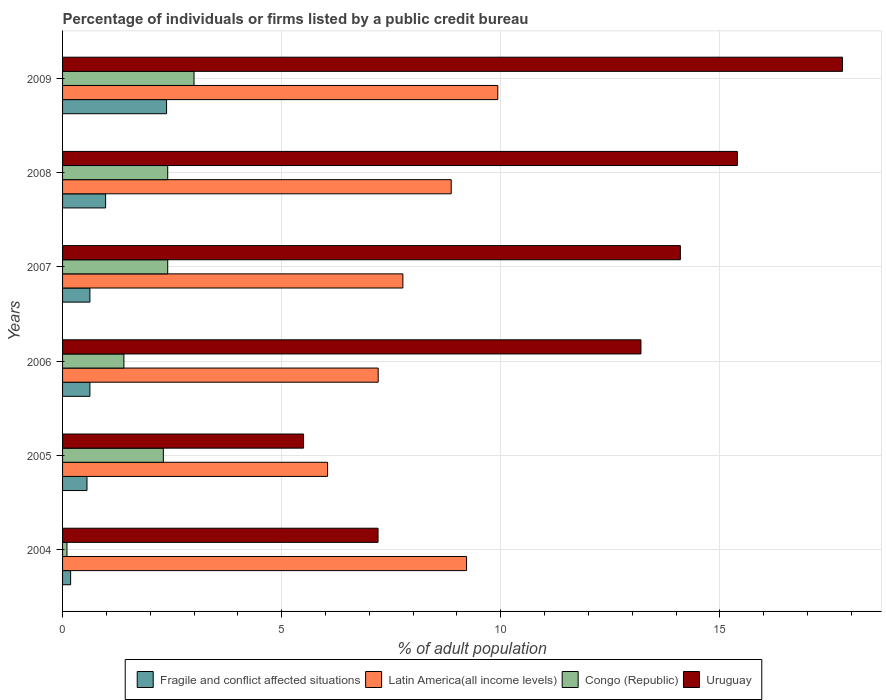Are the number of bars per tick equal to the number of legend labels?
Keep it short and to the point. Yes. Are the number of bars on each tick of the Y-axis equal?
Your response must be concise. Yes. How many bars are there on the 2nd tick from the top?
Your answer should be very brief. 4. What is the label of the 3rd group of bars from the top?
Offer a terse response. 2007. What is the percentage of population listed by a public credit bureau in Latin America(all income levels) in 2006?
Keep it short and to the point. 7.2. Across all years, what is the minimum percentage of population listed by a public credit bureau in Fragile and conflict affected situations?
Your response must be concise. 0.18. In which year was the percentage of population listed by a public credit bureau in Latin America(all income levels) minimum?
Ensure brevity in your answer.  2005. What is the total percentage of population listed by a public credit bureau in Fragile and conflict affected situations in the graph?
Provide a succinct answer. 5.35. What is the difference between the percentage of population listed by a public credit bureau in Congo (Republic) in 2004 and that in 2007?
Provide a short and direct response. -2.3. What is the difference between the percentage of population listed by a public credit bureau in Latin America(all income levels) in 2006 and the percentage of population listed by a public credit bureau in Uruguay in 2008?
Your response must be concise. -8.2. What is the average percentage of population listed by a public credit bureau in Fragile and conflict affected situations per year?
Keep it short and to the point. 0.89. In the year 2007, what is the difference between the percentage of population listed by a public credit bureau in Congo (Republic) and percentage of population listed by a public credit bureau in Latin America(all income levels)?
Offer a very short reply. -5.37. In how many years, is the percentage of population listed by a public credit bureau in Fragile and conflict affected situations greater than 2 %?
Give a very brief answer. 1. What is the ratio of the percentage of population listed by a public credit bureau in Fragile and conflict affected situations in 2004 to that in 2006?
Offer a terse response. 0.29. Is the percentage of population listed by a public credit bureau in Fragile and conflict affected situations in 2006 less than that in 2009?
Provide a succinct answer. Yes. Is the difference between the percentage of population listed by a public credit bureau in Congo (Republic) in 2006 and 2008 greater than the difference between the percentage of population listed by a public credit bureau in Latin America(all income levels) in 2006 and 2008?
Keep it short and to the point. Yes. What is the difference between the highest and the second highest percentage of population listed by a public credit bureau in Fragile and conflict affected situations?
Your response must be concise. 1.39. What does the 3rd bar from the top in 2006 represents?
Keep it short and to the point. Latin America(all income levels). What does the 3rd bar from the bottom in 2009 represents?
Your answer should be compact. Congo (Republic). Is it the case that in every year, the sum of the percentage of population listed by a public credit bureau in Latin America(all income levels) and percentage of population listed by a public credit bureau in Uruguay is greater than the percentage of population listed by a public credit bureau in Fragile and conflict affected situations?
Your response must be concise. Yes. How many bars are there?
Keep it short and to the point. 24. What is the difference between two consecutive major ticks on the X-axis?
Ensure brevity in your answer.  5. Where does the legend appear in the graph?
Make the answer very short. Bottom center. How many legend labels are there?
Your answer should be very brief. 4. What is the title of the graph?
Provide a succinct answer. Percentage of individuals or firms listed by a public credit bureau. Does "Lao PDR" appear as one of the legend labels in the graph?
Provide a short and direct response. No. What is the label or title of the X-axis?
Provide a short and direct response. % of adult population. What is the % of adult population in Fragile and conflict affected situations in 2004?
Your answer should be compact. 0.18. What is the % of adult population of Latin America(all income levels) in 2004?
Your response must be concise. 9.22. What is the % of adult population of Congo (Republic) in 2004?
Your answer should be compact. 0.1. What is the % of adult population of Uruguay in 2004?
Offer a very short reply. 7.2. What is the % of adult population in Fragile and conflict affected situations in 2005?
Provide a succinct answer. 0.56. What is the % of adult population of Latin America(all income levels) in 2005?
Offer a very short reply. 6.05. What is the % of adult population of Uruguay in 2005?
Keep it short and to the point. 5.5. What is the % of adult population of Fragile and conflict affected situations in 2006?
Your answer should be compact. 0.62. What is the % of adult population of Latin America(all income levels) in 2006?
Your response must be concise. 7.2. What is the % of adult population in Congo (Republic) in 2006?
Offer a very short reply. 1.4. What is the % of adult population in Fragile and conflict affected situations in 2007?
Make the answer very short. 0.62. What is the % of adult population in Latin America(all income levels) in 2007?
Your answer should be very brief. 7.77. What is the % of adult population in Fragile and conflict affected situations in 2008?
Make the answer very short. 0.98. What is the % of adult population in Latin America(all income levels) in 2008?
Give a very brief answer. 8.87. What is the % of adult population in Uruguay in 2008?
Provide a short and direct response. 15.4. What is the % of adult population of Fragile and conflict affected situations in 2009?
Provide a short and direct response. 2.37. What is the % of adult population in Latin America(all income levels) in 2009?
Keep it short and to the point. 9.93. Across all years, what is the maximum % of adult population of Fragile and conflict affected situations?
Offer a terse response. 2.37. Across all years, what is the maximum % of adult population in Latin America(all income levels)?
Provide a short and direct response. 9.93. Across all years, what is the maximum % of adult population in Uruguay?
Your answer should be very brief. 17.8. Across all years, what is the minimum % of adult population of Fragile and conflict affected situations?
Offer a very short reply. 0.18. Across all years, what is the minimum % of adult population in Latin America(all income levels)?
Offer a very short reply. 6.05. Across all years, what is the minimum % of adult population in Congo (Republic)?
Offer a terse response. 0.1. Across all years, what is the minimum % of adult population in Uruguay?
Keep it short and to the point. 5.5. What is the total % of adult population in Fragile and conflict affected situations in the graph?
Keep it short and to the point. 5.35. What is the total % of adult population of Latin America(all income levels) in the graph?
Offer a very short reply. 49.04. What is the total % of adult population of Congo (Republic) in the graph?
Your answer should be very brief. 11.6. What is the total % of adult population of Uruguay in the graph?
Provide a short and direct response. 73.2. What is the difference between the % of adult population of Fragile and conflict affected situations in 2004 and that in 2005?
Ensure brevity in your answer.  -0.37. What is the difference between the % of adult population in Latin America(all income levels) in 2004 and that in 2005?
Offer a very short reply. 3.17. What is the difference between the % of adult population in Uruguay in 2004 and that in 2005?
Your response must be concise. 1.7. What is the difference between the % of adult population of Fragile and conflict affected situations in 2004 and that in 2006?
Offer a very short reply. -0.44. What is the difference between the % of adult population in Latin America(all income levels) in 2004 and that in 2006?
Ensure brevity in your answer.  2.02. What is the difference between the % of adult population in Fragile and conflict affected situations in 2004 and that in 2007?
Provide a short and direct response. -0.44. What is the difference between the % of adult population of Latin America(all income levels) in 2004 and that in 2007?
Your answer should be compact. 1.45. What is the difference between the % of adult population in Congo (Republic) in 2004 and that in 2007?
Your response must be concise. -2.3. What is the difference between the % of adult population in Fragile and conflict affected situations in 2004 and that in 2008?
Offer a very short reply. -0.8. What is the difference between the % of adult population of Latin America(all income levels) in 2004 and that in 2008?
Provide a short and direct response. 0.35. What is the difference between the % of adult population of Fragile and conflict affected situations in 2004 and that in 2009?
Give a very brief answer. -2.19. What is the difference between the % of adult population of Latin America(all income levels) in 2004 and that in 2009?
Your response must be concise. -0.71. What is the difference between the % of adult population of Fragile and conflict affected situations in 2005 and that in 2006?
Offer a terse response. -0.07. What is the difference between the % of adult population in Latin America(all income levels) in 2005 and that in 2006?
Provide a short and direct response. -1.16. What is the difference between the % of adult population in Fragile and conflict affected situations in 2005 and that in 2007?
Your response must be concise. -0.07. What is the difference between the % of adult population in Latin America(all income levels) in 2005 and that in 2007?
Your answer should be very brief. -1.72. What is the difference between the % of adult population of Congo (Republic) in 2005 and that in 2007?
Provide a short and direct response. -0.1. What is the difference between the % of adult population in Fragile and conflict affected situations in 2005 and that in 2008?
Offer a terse response. -0.43. What is the difference between the % of adult population of Latin America(all income levels) in 2005 and that in 2008?
Provide a succinct answer. -2.82. What is the difference between the % of adult population of Fragile and conflict affected situations in 2005 and that in 2009?
Your answer should be very brief. -1.82. What is the difference between the % of adult population of Latin America(all income levels) in 2005 and that in 2009?
Give a very brief answer. -3.89. What is the difference between the % of adult population in Congo (Republic) in 2005 and that in 2009?
Keep it short and to the point. -0.7. What is the difference between the % of adult population of Latin America(all income levels) in 2006 and that in 2007?
Ensure brevity in your answer.  -0.56. What is the difference between the % of adult population in Congo (Republic) in 2006 and that in 2007?
Your answer should be very brief. -1. What is the difference between the % of adult population of Uruguay in 2006 and that in 2007?
Provide a succinct answer. -0.9. What is the difference between the % of adult population of Fragile and conflict affected situations in 2006 and that in 2008?
Make the answer very short. -0.36. What is the difference between the % of adult population of Latin America(all income levels) in 2006 and that in 2008?
Offer a terse response. -1.67. What is the difference between the % of adult population of Congo (Republic) in 2006 and that in 2008?
Your response must be concise. -1. What is the difference between the % of adult population in Uruguay in 2006 and that in 2008?
Offer a terse response. -2.2. What is the difference between the % of adult population of Fragile and conflict affected situations in 2006 and that in 2009?
Offer a very short reply. -1.75. What is the difference between the % of adult population of Latin America(all income levels) in 2006 and that in 2009?
Make the answer very short. -2.73. What is the difference between the % of adult population of Uruguay in 2006 and that in 2009?
Your response must be concise. -4.6. What is the difference between the % of adult population in Fragile and conflict affected situations in 2007 and that in 2008?
Provide a succinct answer. -0.36. What is the difference between the % of adult population of Latin America(all income levels) in 2007 and that in 2008?
Your response must be concise. -1.1. What is the difference between the % of adult population in Uruguay in 2007 and that in 2008?
Ensure brevity in your answer.  -1.3. What is the difference between the % of adult population in Fragile and conflict affected situations in 2007 and that in 2009?
Give a very brief answer. -1.75. What is the difference between the % of adult population in Latin America(all income levels) in 2007 and that in 2009?
Your answer should be very brief. -2.17. What is the difference between the % of adult population in Congo (Republic) in 2007 and that in 2009?
Provide a succinct answer. -0.6. What is the difference between the % of adult population of Fragile and conflict affected situations in 2008 and that in 2009?
Ensure brevity in your answer.  -1.39. What is the difference between the % of adult population in Latin America(all income levels) in 2008 and that in 2009?
Provide a succinct answer. -1.06. What is the difference between the % of adult population of Congo (Republic) in 2008 and that in 2009?
Offer a very short reply. -0.6. What is the difference between the % of adult population in Uruguay in 2008 and that in 2009?
Your answer should be compact. -2.4. What is the difference between the % of adult population of Fragile and conflict affected situations in 2004 and the % of adult population of Latin America(all income levels) in 2005?
Provide a short and direct response. -5.86. What is the difference between the % of adult population of Fragile and conflict affected situations in 2004 and the % of adult population of Congo (Republic) in 2005?
Offer a very short reply. -2.12. What is the difference between the % of adult population in Fragile and conflict affected situations in 2004 and the % of adult population in Uruguay in 2005?
Offer a terse response. -5.32. What is the difference between the % of adult population in Latin America(all income levels) in 2004 and the % of adult population in Congo (Republic) in 2005?
Provide a short and direct response. 6.92. What is the difference between the % of adult population of Latin America(all income levels) in 2004 and the % of adult population of Uruguay in 2005?
Give a very brief answer. 3.72. What is the difference between the % of adult population of Congo (Republic) in 2004 and the % of adult population of Uruguay in 2005?
Offer a terse response. -5.4. What is the difference between the % of adult population of Fragile and conflict affected situations in 2004 and the % of adult population of Latin America(all income levels) in 2006?
Keep it short and to the point. -7.02. What is the difference between the % of adult population in Fragile and conflict affected situations in 2004 and the % of adult population in Congo (Republic) in 2006?
Offer a very short reply. -1.22. What is the difference between the % of adult population of Fragile and conflict affected situations in 2004 and the % of adult population of Uruguay in 2006?
Give a very brief answer. -13.02. What is the difference between the % of adult population of Latin America(all income levels) in 2004 and the % of adult population of Congo (Republic) in 2006?
Provide a short and direct response. 7.82. What is the difference between the % of adult population in Latin America(all income levels) in 2004 and the % of adult population in Uruguay in 2006?
Your response must be concise. -3.98. What is the difference between the % of adult population of Fragile and conflict affected situations in 2004 and the % of adult population of Latin America(all income levels) in 2007?
Keep it short and to the point. -7.58. What is the difference between the % of adult population of Fragile and conflict affected situations in 2004 and the % of adult population of Congo (Republic) in 2007?
Give a very brief answer. -2.22. What is the difference between the % of adult population of Fragile and conflict affected situations in 2004 and the % of adult population of Uruguay in 2007?
Offer a terse response. -13.92. What is the difference between the % of adult population in Latin America(all income levels) in 2004 and the % of adult population in Congo (Republic) in 2007?
Give a very brief answer. 6.82. What is the difference between the % of adult population in Latin America(all income levels) in 2004 and the % of adult population in Uruguay in 2007?
Give a very brief answer. -4.88. What is the difference between the % of adult population of Fragile and conflict affected situations in 2004 and the % of adult population of Latin America(all income levels) in 2008?
Offer a very short reply. -8.69. What is the difference between the % of adult population in Fragile and conflict affected situations in 2004 and the % of adult population in Congo (Republic) in 2008?
Keep it short and to the point. -2.22. What is the difference between the % of adult population of Fragile and conflict affected situations in 2004 and the % of adult population of Uruguay in 2008?
Provide a succinct answer. -15.22. What is the difference between the % of adult population in Latin America(all income levels) in 2004 and the % of adult population in Congo (Republic) in 2008?
Keep it short and to the point. 6.82. What is the difference between the % of adult population of Latin America(all income levels) in 2004 and the % of adult population of Uruguay in 2008?
Your answer should be very brief. -6.18. What is the difference between the % of adult population of Congo (Republic) in 2004 and the % of adult population of Uruguay in 2008?
Your answer should be compact. -15.3. What is the difference between the % of adult population of Fragile and conflict affected situations in 2004 and the % of adult population of Latin America(all income levels) in 2009?
Provide a short and direct response. -9.75. What is the difference between the % of adult population of Fragile and conflict affected situations in 2004 and the % of adult population of Congo (Republic) in 2009?
Offer a terse response. -2.82. What is the difference between the % of adult population of Fragile and conflict affected situations in 2004 and the % of adult population of Uruguay in 2009?
Offer a terse response. -17.62. What is the difference between the % of adult population of Latin America(all income levels) in 2004 and the % of adult population of Congo (Republic) in 2009?
Keep it short and to the point. 6.22. What is the difference between the % of adult population of Latin America(all income levels) in 2004 and the % of adult population of Uruguay in 2009?
Provide a succinct answer. -8.58. What is the difference between the % of adult population of Congo (Republic) in 2004 and the % of adult population of Uruguay in 2009?
Your answer should be very brief. -17.7. What is the difference between the % of adult population of Fragile and conflict affected situations in 2005 and the % of adult population of Latin America(all income levels) in 2006?
Your answer should be compact. -6.65. What is the difference between the % of adult population of Fragile and conflict affected situations in 2005 and the % of adult population of Congo (Republic) in 2006?
Give a very brief answer. -0.84. What is the difference between the % of adult population of Fragile and conflict affected situations in 2005 and the % of adult population of Uruguay in 2006?
Make the answer very short. -12.64. What is the difference between the % of adult population in Latin America(all income levels) in 2005 and the % of adult population in Congo (Republic) in 2006?
Provide a succinct answer. 4.65. What is the difference between the % of adult population in Latin America(all income levels) in 2005 and the % of adult population in Uruguay in 2006?
Keep it short and to the point. -7.15. What is the difference between the % of adult population in Fragile and conflict affected situations in 2005 and the % of adult population in Latin America(all income levels) in 2007?
Provide a short and direct response. -7.21. What is the difference between the % of adult population in Fragile and conflict affected situations in 2005 and the % of adult population in Congo (Republic) in 2007?
Provide a short and direct response. -1.84. What is the difference between the % of adult population in Fragile and conflict affected situations in 2005 and the % of adult population in Uruguay in 2007?
Give a very brief answer. -13.54. What is the difference between the % of adult population of Latin America(all income levels) in 2005 and the % of adult population of Congo (Republic) in 2007?
Provide a succinct answer. 3.65. What is the difference between the % of adult population in Latin America(all income levels) in 2005 and the % of adult population in Uruguay in 2007?
Your answer should be compact. -8.05. What is the difference between the % of adult population in Congo (Republic) in 2005 and the % of adult population in Uruguay in 2007?
Your answer should be very brief. -11.8. What is the difference between the % of adult population of Fragile and conflict affected situations in 2005 and the % of adult population of Latin America(all income levels) in 2008?
Provide a short and direct response. -8.31. What is the difference between the % of adult population in Fragile and conflict affected situations in 2005 and the % of adult population in Congo (Republic) in 2008?
Offer a very short reply. -1.84. What is the difference between the % of adult population of Fragile and conflict affected situations in 2005 and the % of adult population of Uruguay in 2008?
Provide a short and direct response. -14.84. What is the difference between the % of adult population in Latin America(all income levels) in 2005 and the % of adult population in Congo (Republic) in 2008?
Your answer should be very brief. 3.65. What is the difference between the % of adult population of Latin America(all income levels) in 2005 and the % of adult population of Uruguay in 2008?
Provide a short and direct response. -9.35. What is the difference between the % of adult population in Congo (Republic) in 2005 and the % of adult population in Uruguay in 2008?
Your response must be concise. -13.1. What is the difference between the % of adult population of Fragile and conflict affected situations in 2005 and the % of adult population of Latin America(all income levels) in 2009?
Provide a succinct answer. -9.38. What is the difference between the % of adult population in Fragile and conflict affected situations in 2005 and the % of adult population in Congo (Republic) in 2009?
Your answer should be compact. -2.44. What is the difference between the % of adult population of Fragile and conflict affected situations in 2005 and the % of adult population of Uruguay in 2009?
Provide a short and direct response. -17.24. What is the difference between the % of adult population in Latin America(all income levels) in 2005 and the % of adult population in Congo (Republic) in 2009?
Offer a very short reply. 3.05. What is the difference between the % of adult population in Latin America(all income levels) in 2005 and the % of adult population in Uruguay in 2009?
Ensure brevity in your answer.  -11.75. What is the difference between the % of adult population in Congo (Republic) in 2005 and the % of adult population in Uruguay in 2009?
Ensure brevity in your answer.  -15.5. What is the difference between the % of adult population of Fragile and conflict affected situations in 2006 and the % of adult population of Latin America(all income levels) in 2007?
Make the answer very short. -7.14. What is the difference between the % of adult population in Fragile and conflict affected situations in 2006 and the % of adult population in Congo (Republic) in 2007?
Make the answer very short. -1.78. What is the difference between the % of adult population of Fragile and conflict affected situations in 2006 and the % of adult population of Uruguay in 2007?
Make the answer very short. -13.48. What is the difference between the % of adult population in Latin America(all income levels) in 2006 and the % of adult population in Congo (Republic) in 2007?
Your answer should be very brief. 4.8. What is the difference between the % of adult population of Latin America(all income levels) in 2006 and the % of adult population of Uruguay in 2007?
Provide a succinct answer. -6.9. What is the difference between the % of adult population of Fragile and conflict affected situations in 2006 and the % of adult population of Latin America(all income levels) in 2008?
Your answer should be compact. -8.25. What is the difference between the % of adult population of Fragile and conflict affected situations in 2006 and the % of adult population of Congo (Republic) in 2008?
Offer a very short reply. -1.78. What is the difference between the % of adult population of Fragile and conflict affected situations in 2006 and the % of adult population of Uruguay in 2008?
Keep it short and to the point. -14.78. What is the difference between the % of adult population of Latin America(all income levels) in 2006 and the % of adult population of Congo (Republic) in 2008?
Ensure brevity in your answer.  4.8. What is the difference between the % of adult population in Latin America(all income levels) in 2006 and the % of adult population in Uruguay in 2008?
Offer a terse response. -8.2. What is the difference between the % of adult population of Congo (Republic) in 2006 and the % of adult population of Uruguay in 2008?
Offer a very short reply. -14. What is the difference between the % of adult population in Fragile and conflict affected situations in 2006 and the % of adult population in Latin America(all income levels) in 2009?
Offer a terse response. -9.31. What is the difference between the % of adult population of Fragile and conflict affected situations in 2006 and the % of adult population of Congo (Republic) in 2009?
Give a very brief answer. -2.38. What is the difference between the % of adult population of Fragile and conflict affected situations in 2006 and the % of adult population of Uruguay in 2009?
Your answer should be very brief. -17.18. What is the difference between the % of adult population of Latin America(all income levels) in 2006 and the % of adult population of Congo (Republic) in 2009?
Provide a short and direct response. 4.2. What is the difference between the % of adult population of Latin America(all income levels) in 2006 and the % of adult population of Uruguay in 2009?
Keep it short and to the point. -10.6. What is the difference between the % of adult population of Congo (Republic) in 2006 and the % of adult population of Uruguay in 2009?
Offer a terse response. -16.4. What is the difference between the % of adult population in Fragile and conflict affected situations in 2007 and the % of adult population in Latin America(all income levels) in 2008?
Your answer should be compact. -8.25. What is the difference between the % of adult population in Fragile and conflict affected situations in 2007 and the % of adult population in Congo (Republic) in 2008?
Provide a short and direct response. -1.78. What is the difference between the % of adult population in Fragile and conflict affected situations in 2007 and the % of adult population in Uruguay in 2008?
Your answer should be very brief. -14.78. What is the difference between the % of adult population in Latin America(all income levels) in 2007 and the % of adult population in Congo (Republic) in 2008?
Your response must be concise. 5.37. What is the difference between the % of adult population in Latin America(all income levels) in 2007 and the % of adult population in Uruguay in 2008?
Provide a succinct answer. -7.63. What is the difference between the % of adult population in Congo (Republic) in 2007 and the % of adult population in Uruguay in 2008?
Ensure brevity in your answer.  -13. What is the difference between the % of adult population in Fragile and conflict affected situations in 2007 and the % of adult population in Latin America(all income levels) in 2009?
Ensure brevity in your answer.  -9.31. What is the difference between the % of adult population of Fragile and conflict affected situations in 2007 and the % of adult population of Congo (Republic) in 2009?
Keep it short and to the point. -2.38. What is the difference between the % of adult population in Fragile and conflict affected situations in 2007 and the % of adult population in Uruguay in 2009?
Your answer should be very brief. -17.18. What is the difference between the % of adult population of Latin America(all income levels) in 2007 and the % of adult population of Congo (Republic) in 2009?
Offer a very short reply. 4.77. What is the difference between the % of adult population of Latin America(all income levels) in 2007 and the % of adult population of Uruguay in 2009?
Offer a terse response. -10.03. What is the difference between the % of adult population in Congo (Republic) in 2007 and the % of adult population in Uruguay in 2009?
Your answer should be compact. -15.4. What is the difference between the % of adult population in Fragile and conflict affected situations in 2008 and the % of adult population in Latin America(all income levels) in 2009?
Give a very brief answer. -8.95. What is the difference between the % of adult population in Fragile and conflict affected situations in 2008 and the % of adult population in Congo (Republic) in 2009?
Give a very brief answer. -2.02. What is the difference between the % of adult population in Fragile and conflict affected situations in 2008 and the % of adult population in Uruguay in 2009?
Your response must be concise. -16.82. What is the difference between the % of adult population in Latin America(all income levels) in 2008 and the % of adult population in Congo (Republic) in 2009?
Provide a short and direct response. 5.87. What is the difference between the % of adult population of Latin America(all income levels) in 2008 and the % of adult population of Uruguay in 2009?
Make the answer very short. -8.93. What is the difference between the % of adult population of Congo (Republic) in 2008 and the % of adult population of Uruguay in 2009?
Make the answer very short. -15.4. What is the average % of adult population of Fragile and conflict affected situations per year?
Provide a succinct answer. 0.89. What is the average % of adult population of Latin America(all income levels) per year?
Your response must be concise. 8.17. What is the average % of adult population of Congo (Republic) per year?
Offer a terse response. 1.93. In the year 2004, what is the difference between the % of adult population of Fragile and conflict affected situations and % of adult population of Latin America(all income levels)?
Make the answer very short. -9.04. In the year 2004, what is the difference between the % of adult population in Fragile and conflict affected situations and % of adult population in Congo (Republic)?
Your answer should be very brief. 0.08. In the year 2004, what is the difference between the % of adult population in Fragile and conflict affected situations and % of adult population in Uruguay?
Offer a terse response. -7.02. In the year 2004, what is the difference between the % of adult population in Latin America(all income levels) and % of adult population in Congo (Republic)?
Give a very brief answer. 9.12. In the year 2004, what is the difference between the % of adult population in Latin America(all income levels) and % of adult population in Uruguay?
Ensure brevity in your answer.  2.02. In the year 2004, what is the difference between the % of adult population in Congo (Republic) and % of adult population in Uruguay?
Provide a short and direct response. -7.1. In the year 2005, what is the difference between the % of adult population of Fragile and conflict affected situations and % of adult population of Latin America(all income levels)?
Provide a short and direct response. -5.49. In the year 2005, what is the difference between the % of adult population of Fragile and conflict affected situations and % of adult population of Congo (Republic)?
Offer a terse response. -1.74. In the year 2005, what is the difference between the % of adult population of Fragile and conflict affected situations and % of adult population of Uruguay?
Offer a very short reply. -4.94. In the year 2005, what is the difference between the % of adult population in Latin America(all income levels) and % of adult population in Congo (Republic)?
Offer a terse response. 3.75. In the year 2005, what is the difference between the % of adult population in Latin America(all income levels) and % of adult population in Uruguay?
Your answer should be very brief. 0.55. In the year 2005, what is the difference between the % of adult population in Congo (Republic) and % of adult population in Uruguay?
Your response must be concise. -3.2. In the year 2006, what is the difference between the % of adult population of Fragile and conflict affected situations and % of adult population of Latin America(all income levels)?
Make the answer very short. -6.58. In the year 2006, what is the difference between the % of adult population of Fragile and conflict affected situations and % of adult population of Congo (Republic)?
Offer a terse response. -0.78. In the year 2006, what is the difference between the % of adult population of Fragile and conflict affected situations and % of adult population of Uruguay?
Your response must be concise. -12.58. In the year 2006, what is the difference between the % of adult population of Latin America(all income levels) and % of adult population of Congo (Republic)?
Offer a very short reply. 5.8. In the year 2006, what is the difference between the % of adult population of Latin America(all income levels) and % of adult population of Uruguay?
Keep it short and to the point. -6. In the year 2006, what is the difference between the % of adult population of Congo (Republic) and % of adult population of Uruguay?
Make the answer very short. -11.8. In the year 2007, what is the difference between the % of adult population of Fragile and conflict affected situations and % of adult population of Latin America(all income levels)?
Your answer should be compact. -7.14. In the year 2007, what is the difference between the % of adult population in Fragile and conflict affected situations and % of adult population in Congo (Republic)?
Ensure brevity in your answer.  -1.78. In the year 2007, what is the difference between the % of adult population in Fragile and conflict affected situations and % of adult population in Uruguay?
Ensure brevity in your answer.  -13.48. In the year 2007, what is the difference between the % of adult population of Latin America(all income levels) and % of adult population of Congo (Republic)?
Your response must be concise. 5.37. In the year 2007, what is the difference between the % of adult population of Latin America(all income levels) and % of adult population of Uruguay?
Your answer should be compact. -6.33. In the year 2007, what is the difference between the % of adult population in Congo (Republic) and % of adult population in Uruguay?
Make the answer very short. -11.7. In the year 2008, what is the difference between the % of adult population in Fragile and conflict affected situations and % of adult population in Latin America(all income levels)?
Ensure brevity in your answer.  -7.89. In the year 2008, what is the difference between the % of adult population of Fragile and conflict affected situations and % of adult population of Congo (Republic)?
Keep it short and to the point. -1.42. In the year 2008, what is the difference between the % of adult population in Fragile and conflict affected situations and % of adult population in Uruguay?
Ensure brevity in your answer.  -14.42. In the year 2008, what is the difference between the % of adult population of Latin America(all income levels) and % of adult population of Congo (Republic)?
Your response must be concise. 6.47. In the year 2008, what is the difference between the % of adult population of Latin America(all income levels) and % of adult population of Uruguay?
Your answer should be compact. -6.53. In the year 2008, what is the difference between the % of adult population of Congo (Republic) and % of adult population of Uruguay?
Provide a succinct answer. -13. In the year 2009, what is the difference between the % of adult population of Fragile and conflict affected situations and % of adult population of Latin America(all income levels)?
Your response must be concise. -7.56. In the year 2009, what is the difference between the % of adult population of Fragile and conflict affected situations and % of adult population of Congo (Republic)?
Give a very brief answer. -0.63. In the year 2009, what is the difference between the % of adult population of Fragile and conflict affected situations and % of adult population of Uruguay?
Ensure brevity in your answer.  -15.43. In the year 2009, what is the difference between the % of adult population in Latin America(all income levels) and % of adult population in Congo (Republic)?
Give a very brief answer. 6.93. In the year 2009, what is the difference between the % of adult population in Latin America(all income levels) and % of adult population in Uruguay?
Ensure brevity in your answer.  -7.87. In the year 2009, what is the difference between the % of adult population of Congo (Republic) and % of adult population of Uruguay?
Make the answer very short. -14.8. What is the ratio of the % of adult population in Fragile and conflict affected situations in 2004 to that in 2005?
Make the answer very short. 0.33. What is the ratio of the % of adult population of Latin America(all income levels) in 2004 to that in 2005?
Your answer should be compact. 1.52. What is the ratio of the % of adult population of Congo (Republic) in 2004 to that in 2005?
Provide a succinct answer. 0.04. What is the ratio of the % of adult population of Uruguay in 2004 to that in 2005?
Your answer should be compact. 1.31. What is the ratio of the % of adult population in Fragile and conflict affected situations in 2004 to that in 2006?
Give a very brief answer. 0.29. What is the ratio of the % of adult population of Latin America(all income levels) in 2004 to that in 2006?
Your answer should be very brief. 1.28. What is the ratio of the % of adult population of Congo (Republic) in 2004 to that in 2006?
Ensure brevity in your answer.  0.07. What is the ratio of the % of adult population of Uruguay in 2004 to that in 2006?
Offer a very short reply. 0.55. What is the ratio of the % of adult population in Fragile and conflict affected situations in 2004 to that in 2007?
Offer a terse response. 0.29. What is the ratio of the % of adult population in Latin America(all income levels) in 2004 to that in 2007?
Your answer should be compact. 1.19. What is the ratio of the % of adult population of Congo (Republic) in 2004 to that in 2007?
Offer a terse response. 0.04. What is the ratio of the % of adult population in Uruguay in 2004 to that in 2007?
Give a very brief answer. 0.51. What is the ratio of the % of adult population in Fragile and conflict affected situations in 2004 to that in 2008?
Offer a very short reply. 0.19. What is the ratio of the % of adult population in Latin America(all income levels) in 2004 to that in 2008?
Provide a succinct answer. 1.04. What is the ratio of the % of adult population of Congo (Republic) in 2004 to that in 2008?
Your answer should be very brief. 0.04. What is the ratio of the % of adult population of Uruguay in 2004 to that in 2008?
Offer a very short reply. 0.47. What is the ratio of the % of adult population in Fragile and conflict affected situations in 2004 to that in 2009?
Keep it short and to the point. 0.08. What is the ratio of the % of adult population in Latin America(all income levels) in 2004 to that in 2009?
Make the answer very short. 0.93. What is the ratio of the % of adult population in Congo (Republic) in 2004 to that in 2009?
Ensure brevity in your answer.  0.03. What is the ratio of the % of adult population in Uruguay in 2004 to that in 2009?
Your response must be concise. 0.4. What is the ratio of the % of adult population of Fragile and conflict affected situations in 2005 to that in 2006?
Ensure brevity in your answer.  0.89. What is the ratio of the % of adult population of Latin America(all income levels) in 2005 to that in 2006?
Your response must be concise. 0.84. What is the ratio of the % of adult population of Congo (Republic) in 2005 to that in 2006?
Make the answer very short. 1.64. What is the ratio of the % of adult population of Uruguay in 2005 to that in 2006?
Give a very brief answer. 0.42. What is the ratio of the % of adult population in Fragile and conflict affected situations in 2005 to that in 2007?
Your answer should be very brief. 0.89. What is the ratio of the % of adult population in Latin America(all income levels) in 2005 to that in 2007?
Your answer should be very brief. 0.78. What is the ratio of the % of adult population of Uruguay in 2005 to that in 2007?
Your answer should be compact. 0.39. What is the ratio of the % of adult population of Fragile and conflict affected situations in 2005 to that in 2008?
Make the answer very short. 0.57. What is the ratio of the % of adult population in Latin America(all income levels) in 2005 to that in 2008?
Provide a succinct answer. 0.68. What is the ratio of the % of adult population of Uruguay in 2005 to that in 2008?
Provide a short and direct response. 0.36. What is the ratio of the % of adult population of Fragile and conflict affected situations in 2005 to that in 2009?
Ensure brevity in your answer.  0.23. What is the ratio of the % of adult population of Latin America(all income levels) in 2005 to that in 2009?
Your answer should be compact. 0.61. What is the ratio of the % of adult population of Congo (Republic) in 2005 to that in 2009?
Your answer should be compact. 0.77. What is the ratio of the % of adult population of Uruguay in 2005 to that in 2009?
Offer a very short reply. 0.31. What is the ratio of the % of adult population of Latin America(all income levels) in 2006 to that in 2007?
Make the answer very short. 0.93. What is the ratio of the % of adult population of Congo (Republic) in 2006 to that in 2007?
Give a very brief answer. 0.58. What is the ratio of the % of adult population of Uruguay in 2006 to that in 2007?
Ensure brevity in your answer.  0.94. What is the ratio of the % of adult population of Fragile and conflict affected situations in 2006 to that in 2008?
Ensure brevity in your answer.  0.64. What is the ratio of the % of adult population in Latin America(all income levels) in 2006 to that in 2008?
Your response must be concise. 0.81. What is the ratio of the % of adult population of Congo (Republic) in 2006 to that in 2008?
Make the answer very short. 0.58. What is the ratio of the % of adult population in Fragile and conflict affected situations in 2006 to that in 2009?
Provide a short and direct response. 0.26. What is the ratio of the % of adult population in Latin America(all income levels) in 2006 to that in 2009?
Keep it short and to the point. 0.73. What is the ratio of the % of adult population of Congo (Republic) in 2006 to that in 2009?
Provide a short and direct response. 0.47. What is the ratio of the % of adult population of Uruguay in 2006 to that in 2009?
Ensure brevity in your answer.  0.74. What is the ratio of the % of adult population in Fragile and conflict affected situations in 2007 to that in 2008?
Provide a short and direct response. 0.64. What is the ratio of the % of adult population of Latin America(all income levels) in 2007 to that in 2008?
Provide a succinct answer. 0.88. What is the ratio of the % of adult population in Uruguay in 2007 to that in 2008?
Your answer should be very brief. 0.92. What is the ratio of the % of adult population of Fragile and conflict affected situations in 2007 to that in 2009?
Give a very brief answer. 0.26. What is the ratio of the % of adult population in Latin America(all income levels) in 2007 to that in 2009?
Your answer should be very brief. 0.78. What is the ratio of the % of adult population in Uruguay in 2007 to that in 2009?
Your response must be concise. 0.79. What is the ratio of the % of adult population of Fragile and conflict affected situations in 2008 to that in 2009?
Ensure brevity in your answer.  0.41. What is the ratio of the % of adult population in Latin America(all income levels) in 2008 to that in 2009?
Keep it short and to the point. 0.89. What is the ratio of the % of adult population in Uruguay in 2008 to that in 2009?
Make the answer very short. 0.87. What is the difference between the highest and the second highest % of adult population of Fragile and conflict affected situations?
Your response must be concise. 1.39. What is the difference between the highest and the second highest % of adult population of Latin America(all income levels)?
Keep it short and to the point. 0.71. What is the difference between the highest and the second highest % of adult population of Congo (Republic)?
Offer a very short reply. 0.6. What is the difference between the highest and the lowest % of adult population in Fragile and conflict affected situations?
Make the answer very short. 2.19. What is the difference between the highest and the lowest % of adult population in Latin America(all income levels)?
Your answer should be very brief. 3.89. What is the difference between the highest and the lowest % of adult population in Uruguay?
Your answer should be compact. 12.3. 